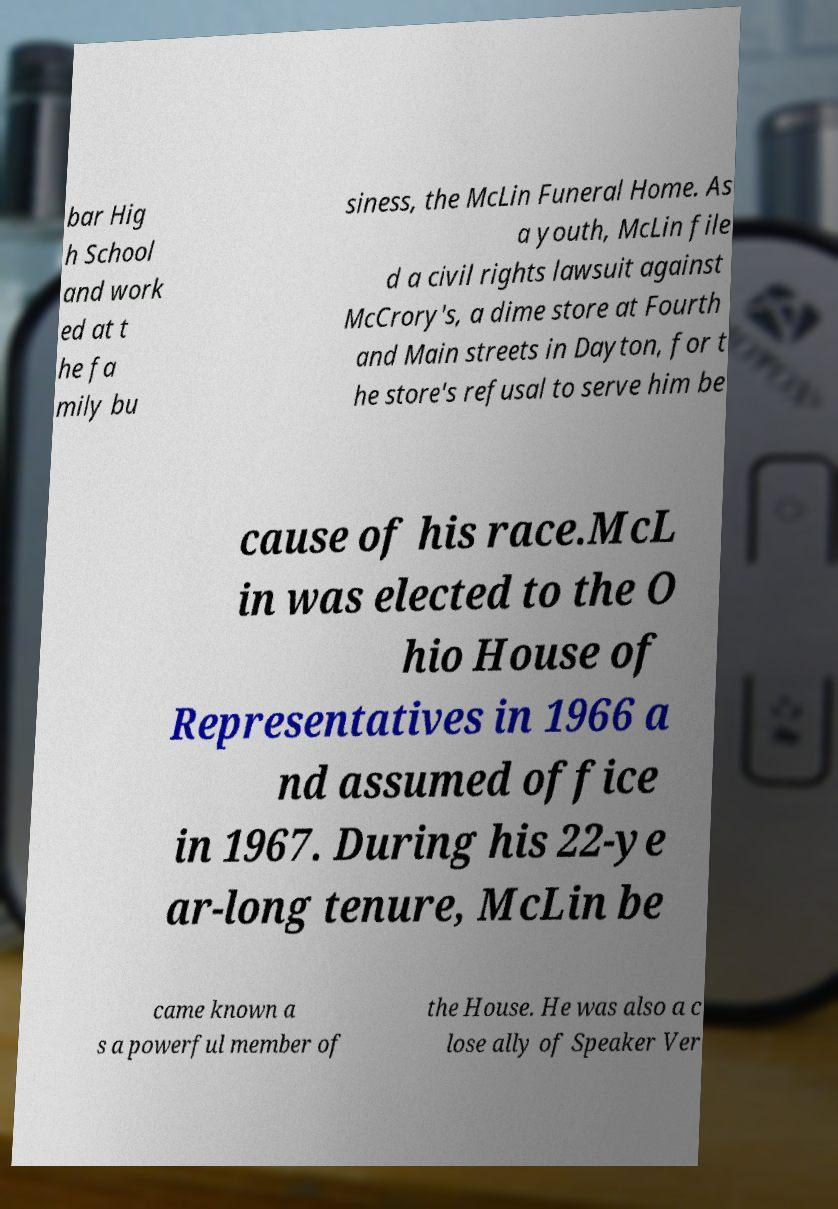What messages or text are displayed in this image? I need them in a readable, typed format. bar Hig h School and work ed at t he fa mily bu siness, the McLin Funeral Home. As a youth, McLin file d a civil rights lawsuit against McCrory's, a dime store at Fourth and Main streets in Dayton, for t he store's refusal to serve him be cause of his race.McL in was elected to the O hio House of Representatives in 1966 a nd assumed office in 1967. During his 22-ye ar-long tenure, McLin be came known a s a powerful member of the House. He was also a c lose ally of Speaker Ver 